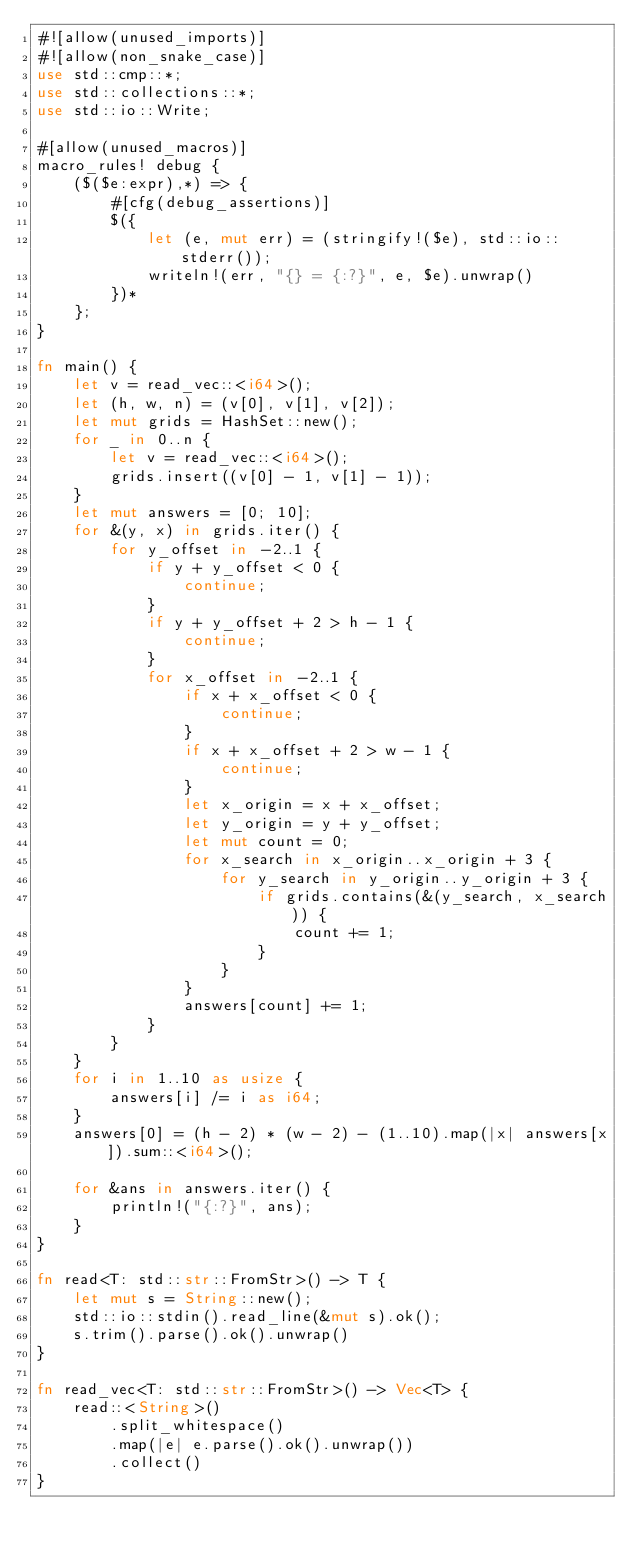<code> <loc_0><loc_0><loc_500><loc_500><_Rust_>#![allow(unused_imports)]
#![allow(non_snake_case)]
use std::cmp::*;
use std::collections::*;
use std::io::Write;

#[allow(unused_macros)]
macro_rules! debug {
    ($($e:expr),*) => {
        #[cfg(debug_assertions)]
        $({
            let (e, mut err) = (stringify!($e), std::io::stderr());
            writeln!(err, "{} = {:?}", e, $e).unwrap()
        })*
    };
}

fn main() {
    let v = read_vec::<i64>();
    let (h, w, n) = (v[0], v[1], v[2]);
    let mut grids = HashSet::new();
    for _ in 0..n {
        let v = read_vec::<i64>();
        grids.insert((v[0] - 1, v[1] - 1));
    }
    let mut answers = [0; 10];
    for &(y, x) in grids.iter() {
        for y_offset in -2..1 {
            if y + y_offset < 0 {
                continue;
            }
            if y + y_offset + 2 > h - 1 {
                continue;
            }
            for x_offset in -2..1 {
                if x + x_offset < 0 {
                    continue;
                }
                if x + x_offset + 2 > w - 1 {
                    continue;
                }
                let x_origin = x + x_offset;
                let y_origin = y + y_offset;
                let mut count = 0;
                for x_search in x_origin..x_origin + 3 {
                    for y_search in y_origin..y_origin + 3 {
                        if grids.contains(&(y_search, x_search)) {
                            count += 1;
                        }
                    }
                }
                answers[count] += 1;
            }
        }
    }
    for i in 1..10 as usize {
        answers[i] /= i as i64;
    }
    answers[0] = (h - 2) * (w - 2) - (1..10).map(|x| answers[x]).sum::<i64>();

    for &ans in answers.iter() {
        println!("{:?}", ans);
    }
}

fn read<T: std::str::FromStr>() -> T {
    let mut s = String::new();
    std::io::stdin().read_line(&mut s).ok();
    s.trim().parse().ok().unwrap()
}

fn read_vec<T: std::str::FromStr>() -> Vec<T> {
    read::<String>()
        .split_whitespace()
        .map(|e| e.parse().ok().unwrap())
        .collect()
}
</code> 